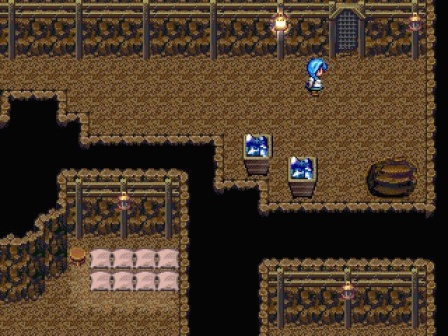What might be contained in the treasure chests to the left? The treasures might hold essential items like health potions, keys for unlocking further areas of the dungeon or rare artifacts that could boost the character's abilities. Given the setting, they might also contain maps or scrolls with hints about navigating the dungeon's challenges. 